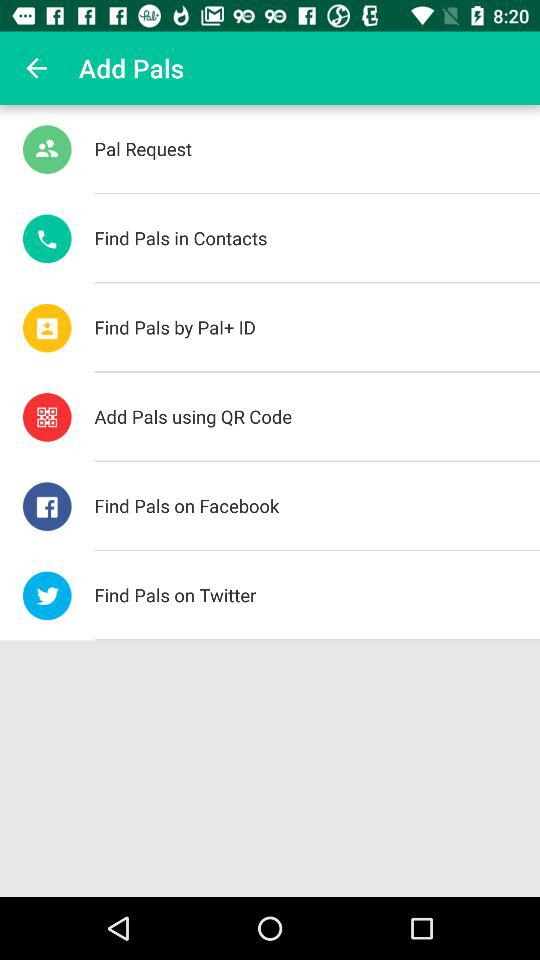How many options are there to find pals?
Answer the question using a single word or phrase. 6 